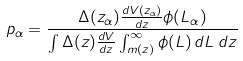Convert formula to latex. <formula><loc_0><loc_0><loc_500><loc_500>p _ { \alpha } = \frac { \Delta ( z _ { \alpha } ) \frac { d V ( z _ { \alpha } ) } { d z } \phi ( L _ { \alpha } ) } { \int \Delta ( z ) \frac { d V } { d z } \int _ { \L m ( z ) } ^ { \infty } \phi ( L ) \, d L \, d z }</formula> 